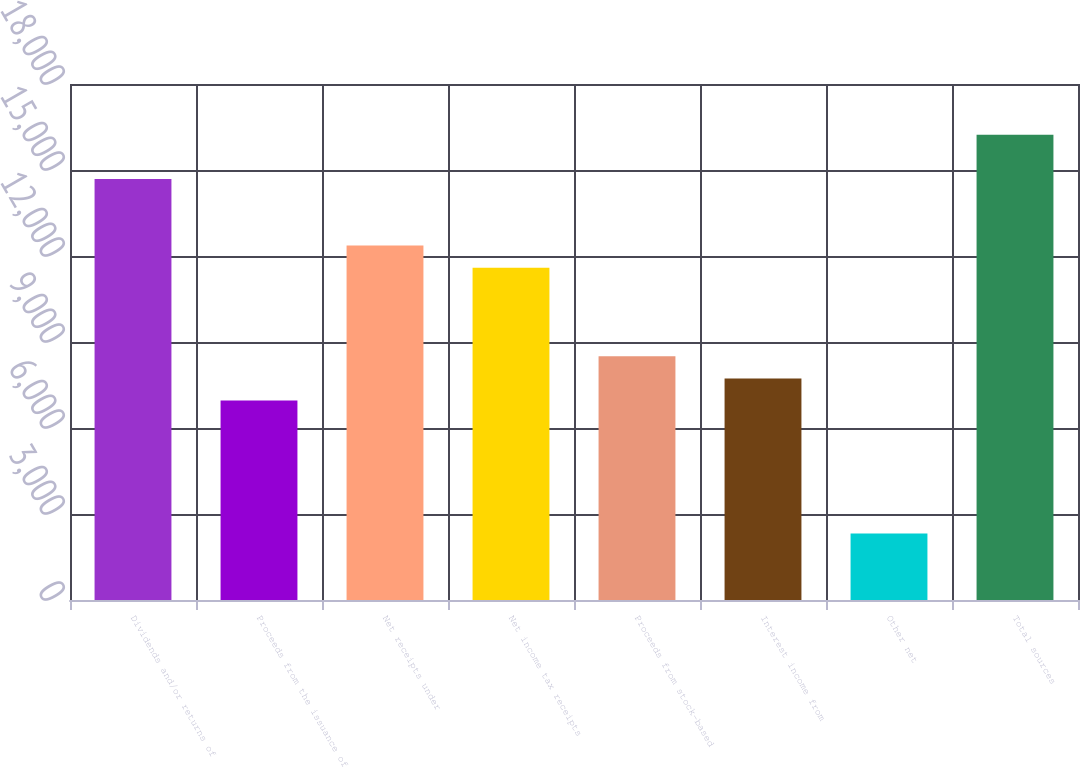Convert chart. <chart><loc_0><loc_0><loc_500><loc_500><bar_chart><fcel>Dividends and/or returns of<fcel>Proceeds from the issuance of<fcel>Net receipts under<fcel>Net income tax receipts<fcel>Proceeds from stock-based<fcel>Interest income from<fcel>Other net<fcel>Total sources<nl><fcel>14683<fcel>6955.24<fcel>12364.7<fcel>11591.9<fcel>8500.8<fcel>7728.02<fcel>2318.56<fcel>16228.6<nl></chart> 